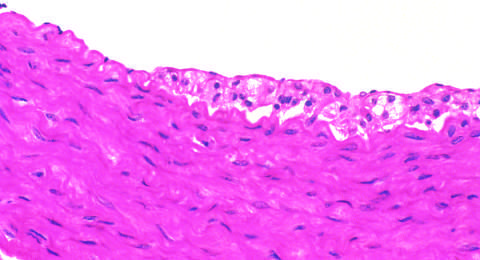does the anomalous area demonstrate intimal, macrophage-derived foam cells?
Answer the question using a single word or phrase. No 